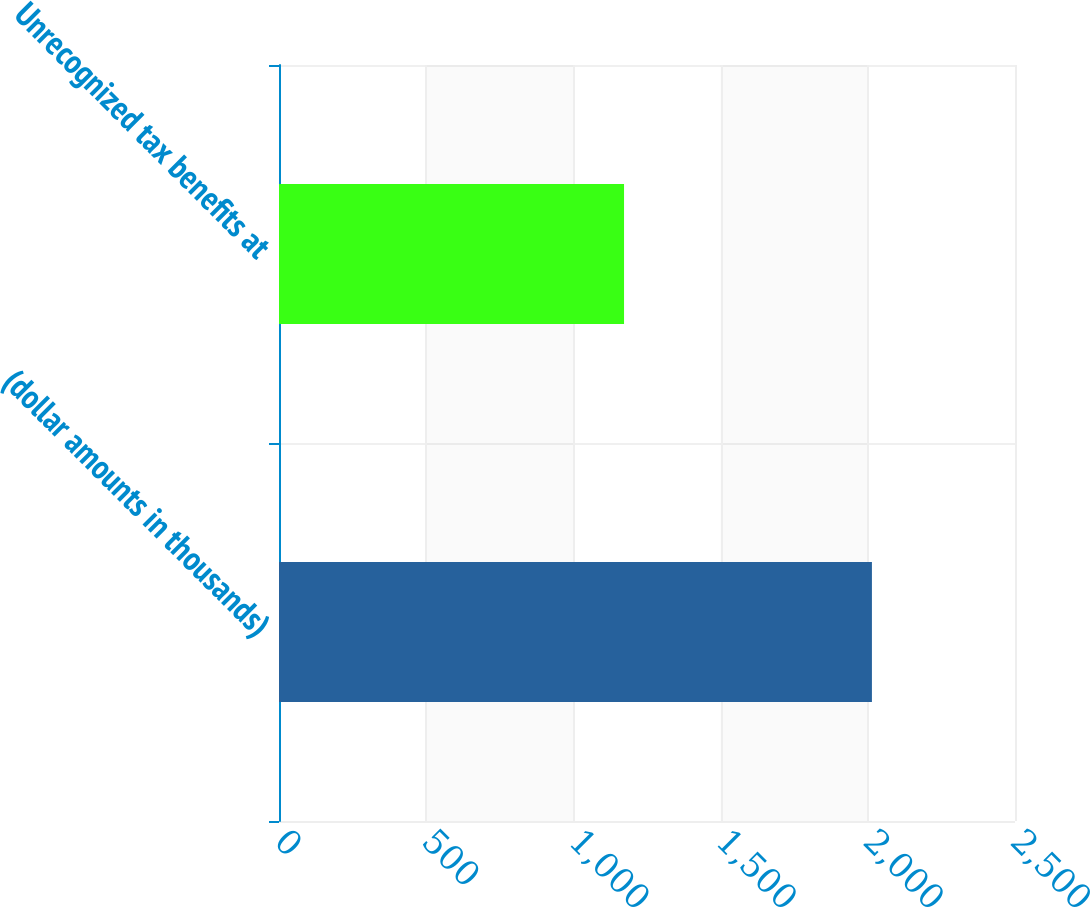Convert chart to OTSL. <chart><loc_0><loc_0><loc_500><loc_500><bar_chart><fcel>(dollar amounts in thousands)<fcel>Unrecognized tax benefits at<nl><fcel>2014<fcel>1172<nl></chart> 